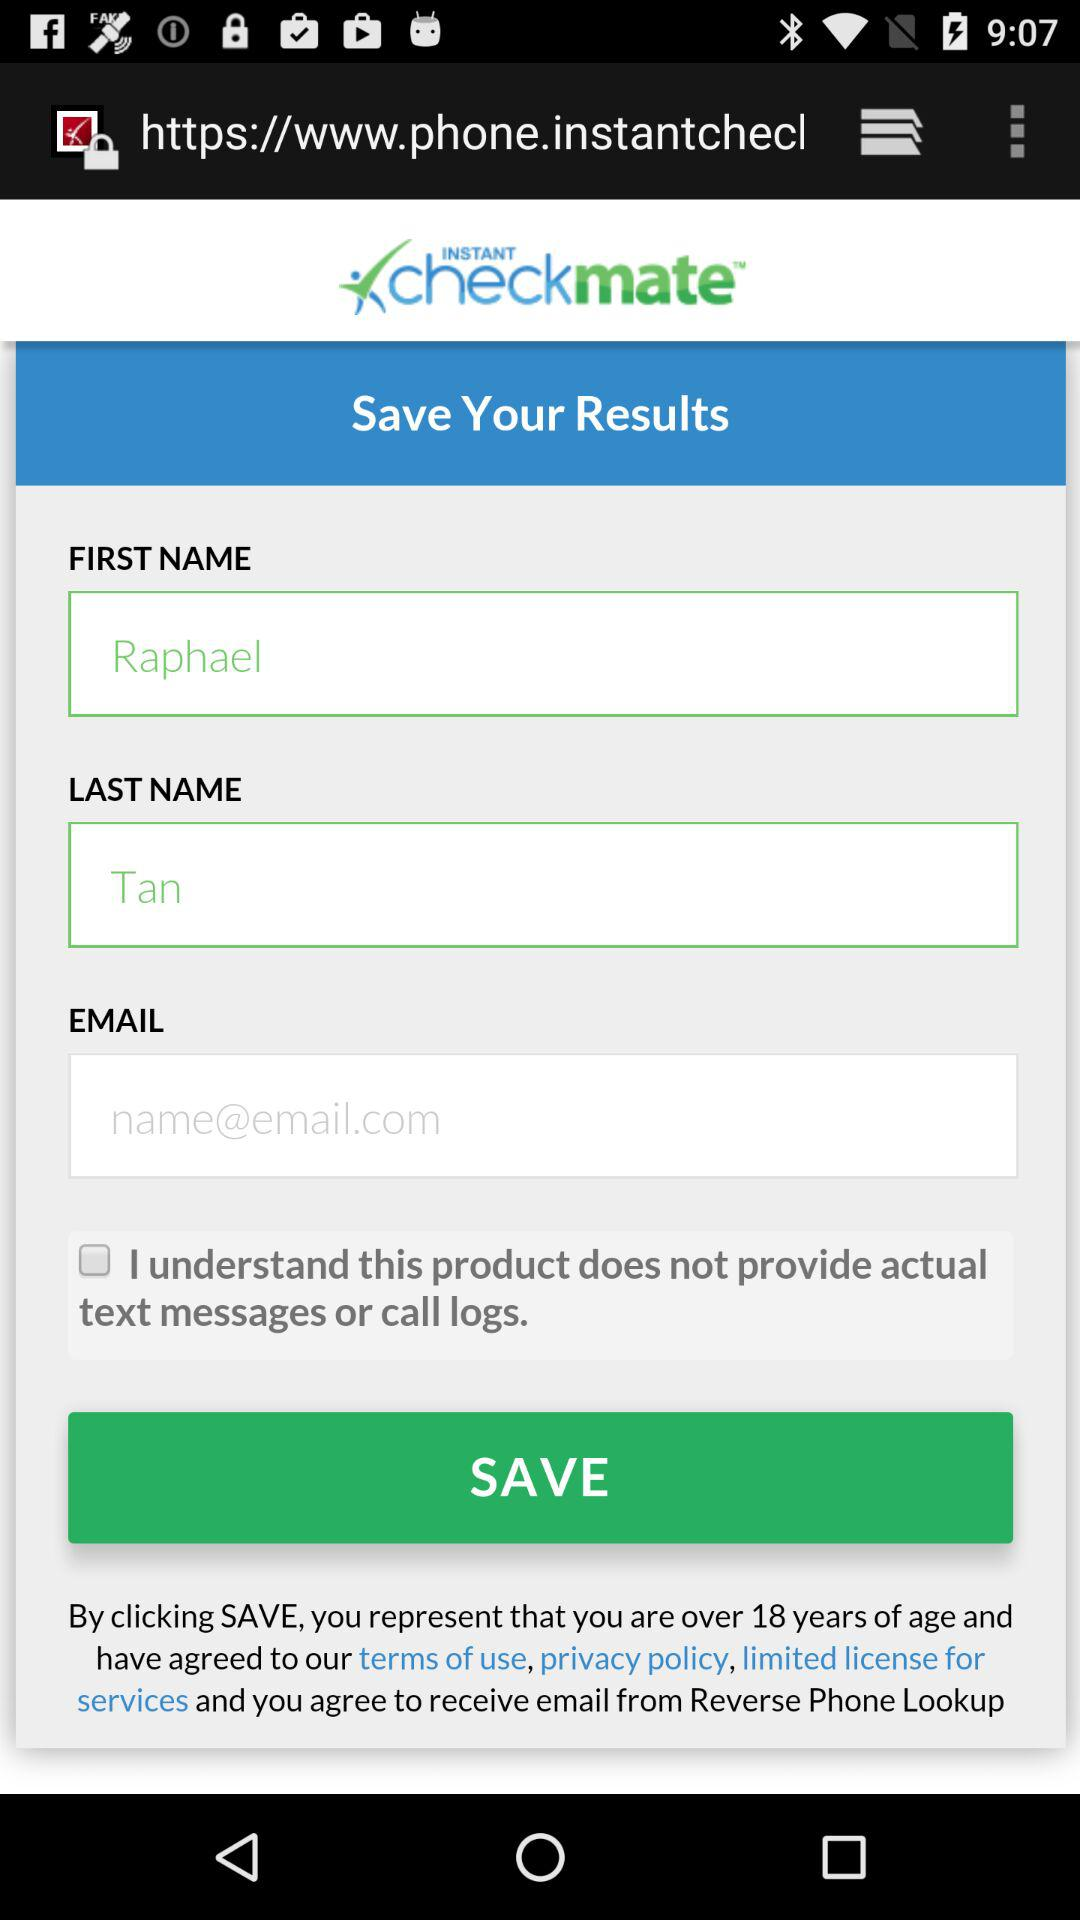What is the status of "I understand this product does not provide actual text messages or call logs"? The status is "off". 